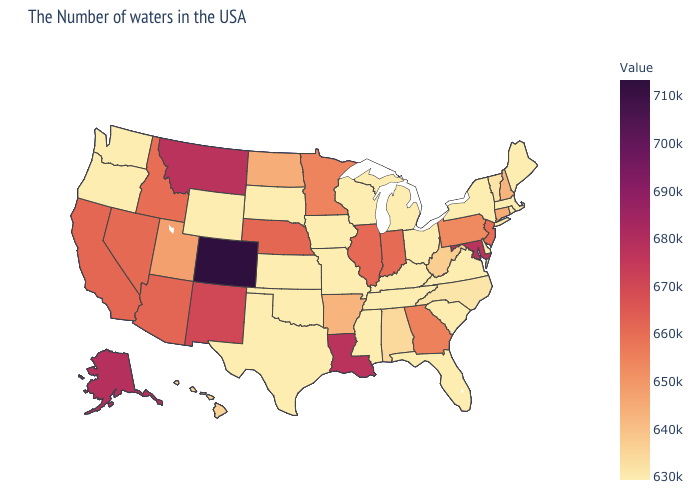Does Nevada have the highest value in the West?
Quick response, please. No. Is the legend a continuous bar?
Be succinct. Yes. Does Alabama have the lowest value in the USA?
Answer briefly. No. 